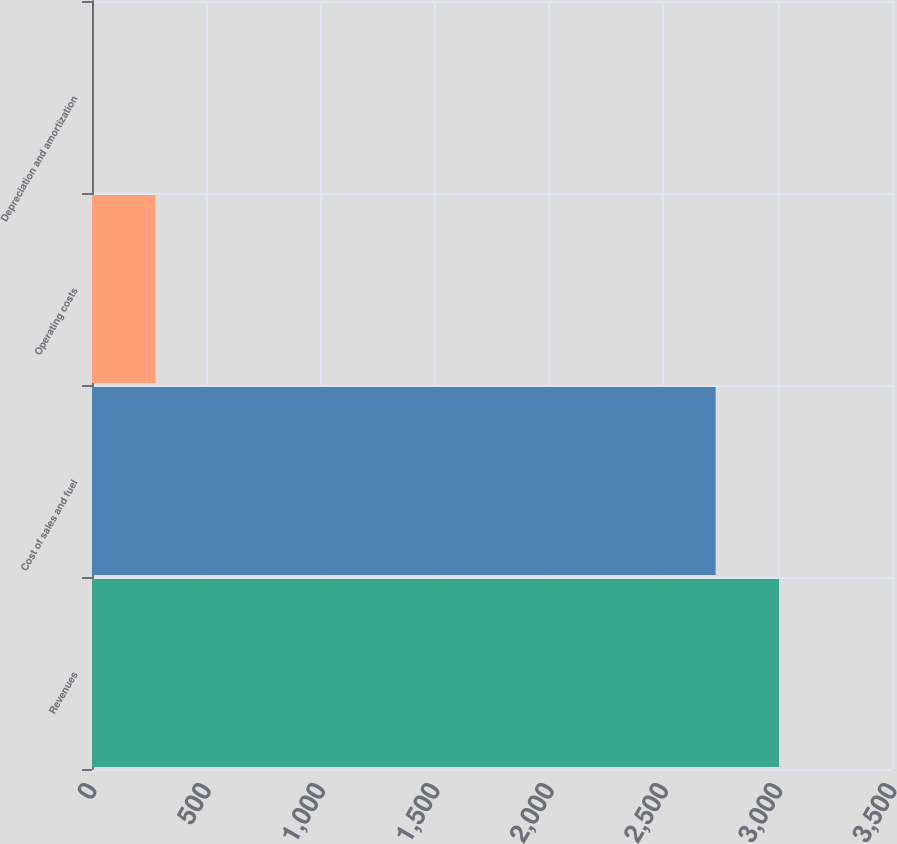<chart> <loc_0><loc_0><loc_500><loc_500><bar_chart><fcel>Revenues<fcel>Cost of sales and fuel<fcel>Operating costs<fcel>Depreciation and amortization<nl><fcel>3006.18<fcel>2728.5<fcel>278.08<fcel>0.4<nl></chart> 